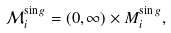Convert formula to latex. <formula><loc_0><loc_0><loc_500><loc_500>\mathcal { M } _ { i } ^ { \sin g } = ( 0 , \infty ) \times M _ { i } ^ { \sin g } ,</formula> 